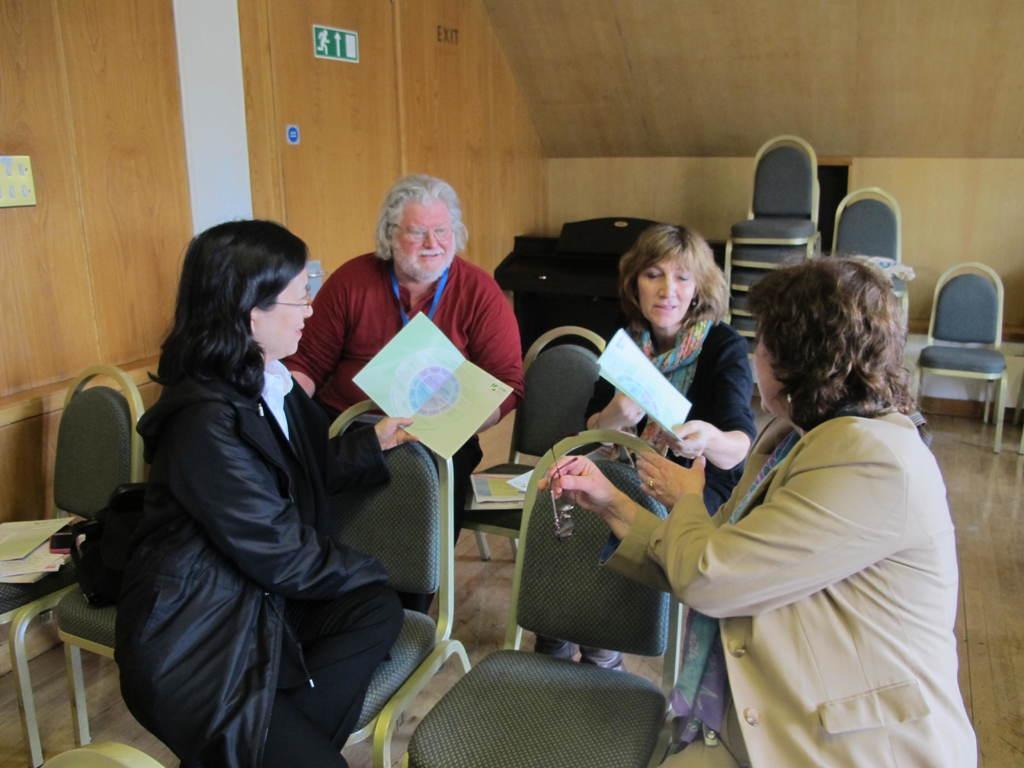Could you give a brief overview of what you see in this image? There are four persons sitting in chairs where two among them are holding green color sheet in their hands. 